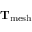Convert formula to latex. <formula><loc_0><loc_0><loc_500><loc_500>T _ { m e s h }</formula> 